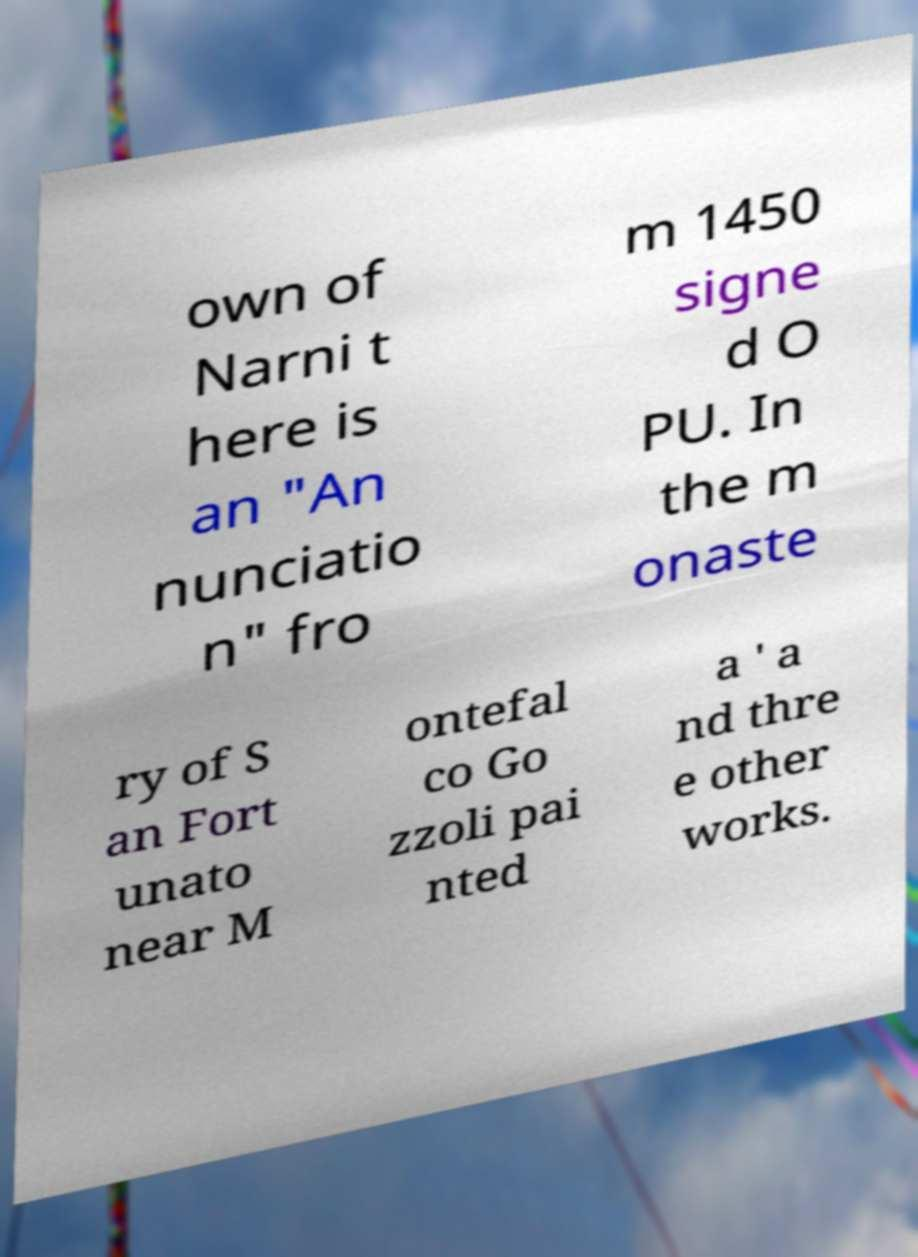Could you extract and type out the text from this image? own of Narni t here is an "An nunciatio n" fro m 1450 signe d O PU. In the m onaste ry of S an Fort unato near M ontefal co Go zzoli pai nted a ' a nd thre e other works. 